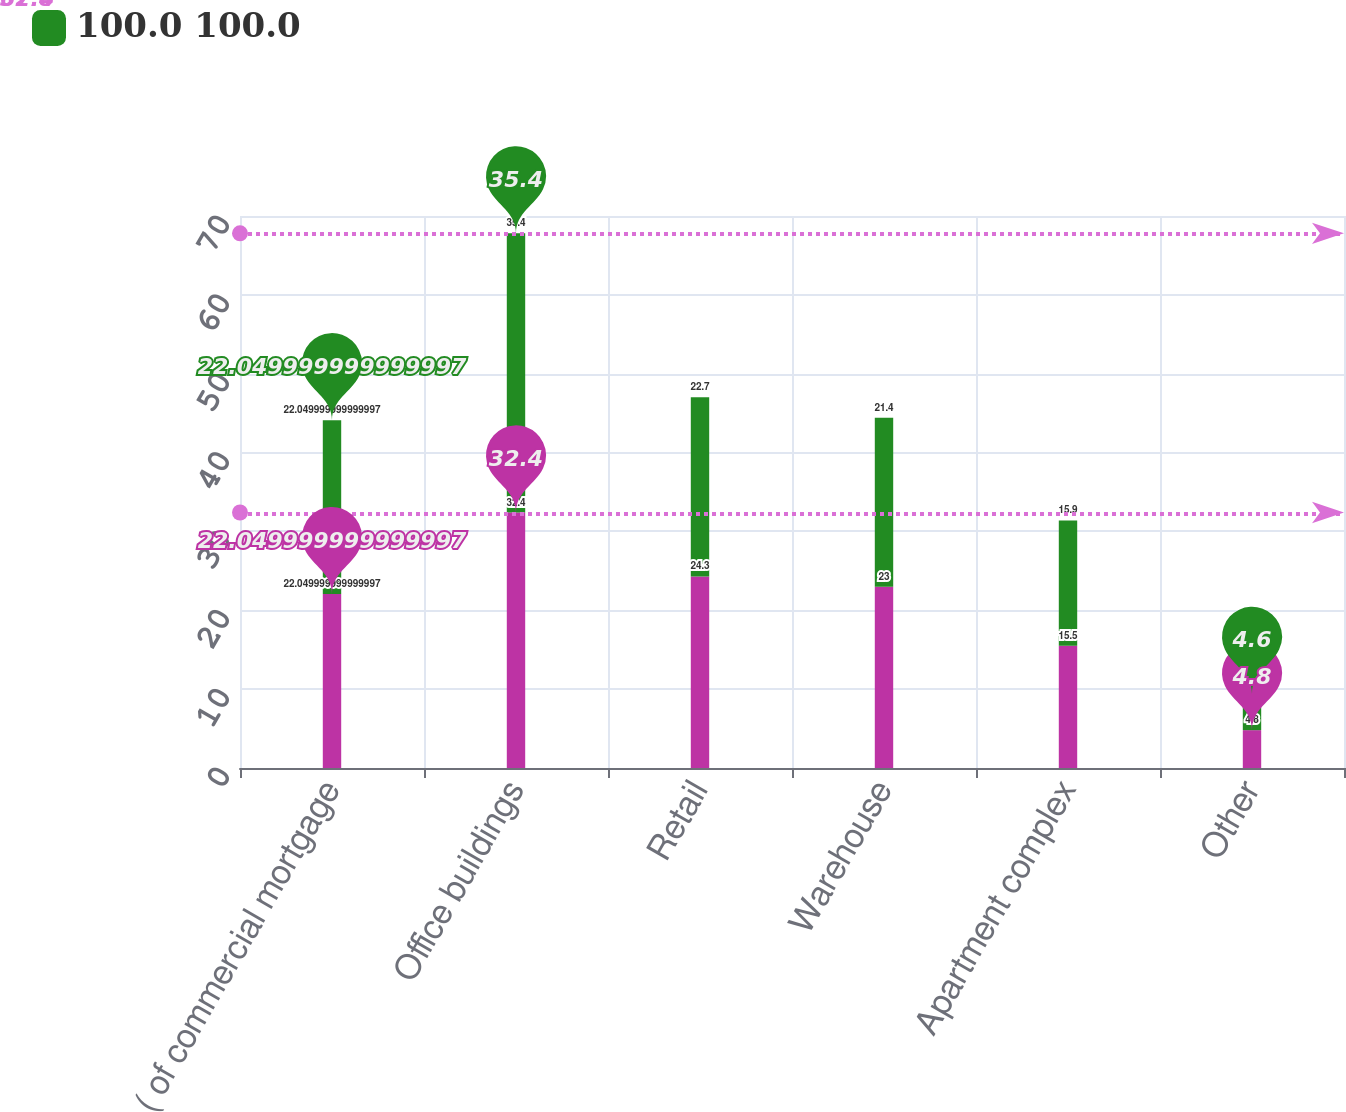Convert chart to OTSL. <chart><loc_0><loc_0><loc_500><loc_500><stacked_bar_chart><ecel><fcel>( of commercial mortgage<fcel>Office buildings<fcel>Retail<fcel>Warehouse<fcel>Apartment complex<fcel>Other<nl><fcel>nan<fcel>22.05<fcel>32.4<fcel>24.3<fcel>23<fcel>15.5<fcel>4.8<nl><fcel>100.0 100.0<fcel>22.05<fcel>35.4<fcel>22.7<fcel>21.4<fcel>15.9<fcel>4.6<nl></chart> 